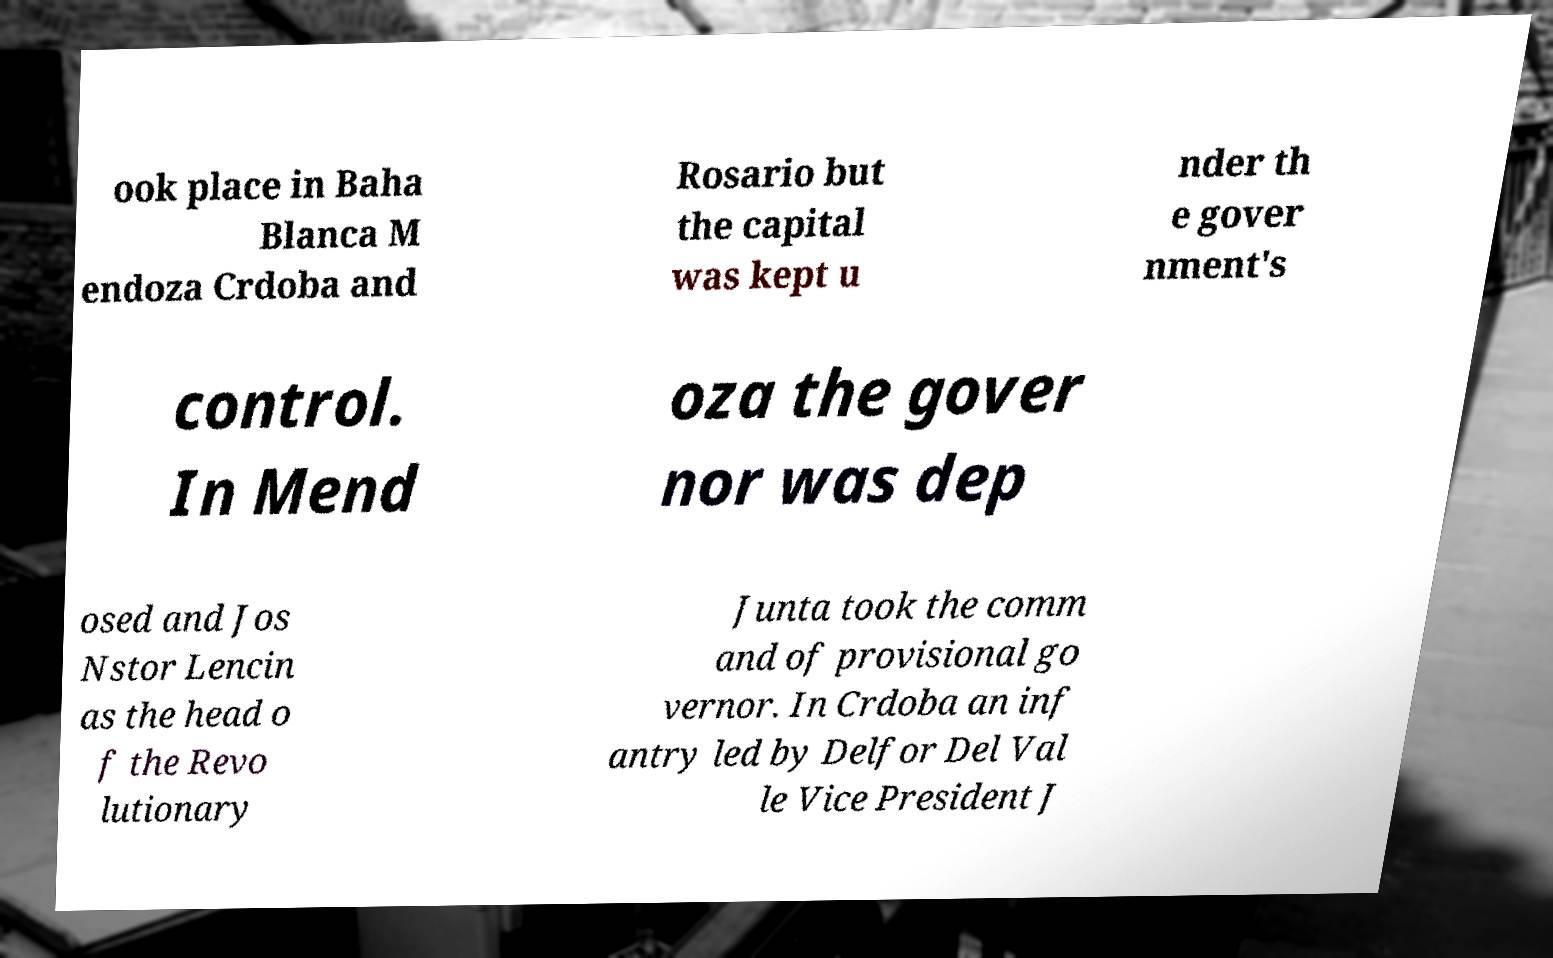I need the written content from this picture converted into text. Can you do that? ook place in Baha Blanca M endoza Crdoba and Rosario but the capital was kept u nder th e gover nment's control. In Mend oza the gover nor was dep osed and Jos Nstor Lencin as the head o f the Revo lutionary Junta took the comm and of provisional go vernor. In Crdoba an inf antry led by Delfor Del Val le Vice President J 